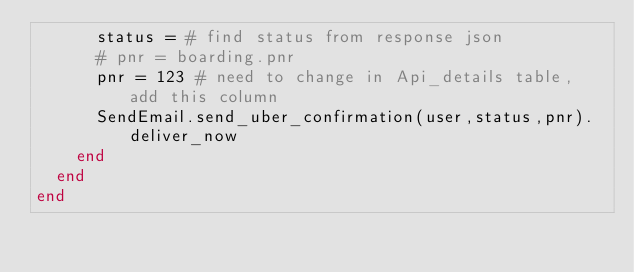Convert code to text. <code><loc_0><loc_0><loc_500><loc_500><_Ruby_>      status = # find status from response json
      # pnr = boarding.pnr
      pnr = 123 # need to change in Api_details table, add this column 
      SendEmail.send_uber_confirmation(user,status,pnr).deliver_now
    end
  end
end
</code> 